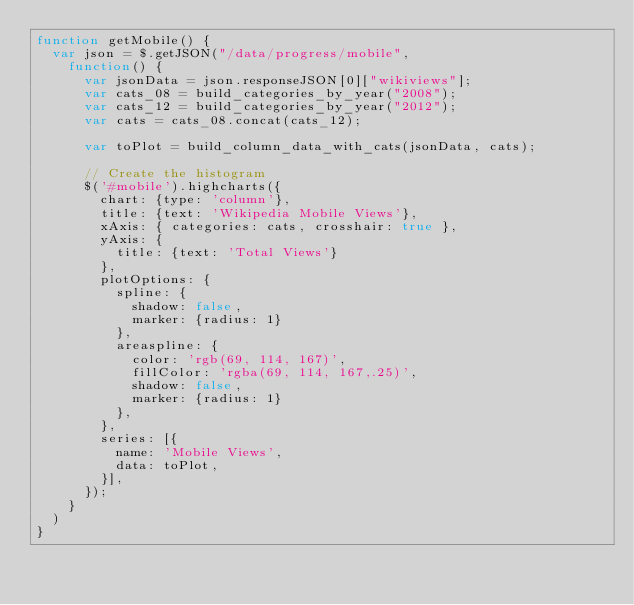<code> <loc_0><loc_0><loc_500><loc_500><_JavaScript_>function getMobile() {
  var json = $.getJSON("/data/progress/mobile",
    function() {
      var jsonData = json.responseJSON[0]["wikiviews"];
      var cats_08 = build_categories_by_year("2008");
      var cats_12 = build_categories_by_year("2012");
      var cats = cats_08.concat(cats_12);

      var toPlot = build_column_data_with_cats(jsonData, cats);

      // Create the histogram
      $('#mobile').highcharts({
        chart: {type: 'column'},
        title: {text: 'Wikipedia Mobile Views'},
        xAxis: { categories: cats, crosshair: true },
        yAxis: {
          title: {text: 'Total Views'}
        },
        plotOptions: {
          spline: {
            shadow: false,
            marker: {radius: 1}
          },
          areaspline: {
            color: 'rgb(69, 114, 167)',
            fillColor: 'rgba(69, 114, 167,.25)',
            shadow: false,
            marker: {radius: 1}
          },
        },
        series: [{
          name: 'Mobile Views',
          data: toPlot,
        }],
      });
    }
  )
}
</code> 